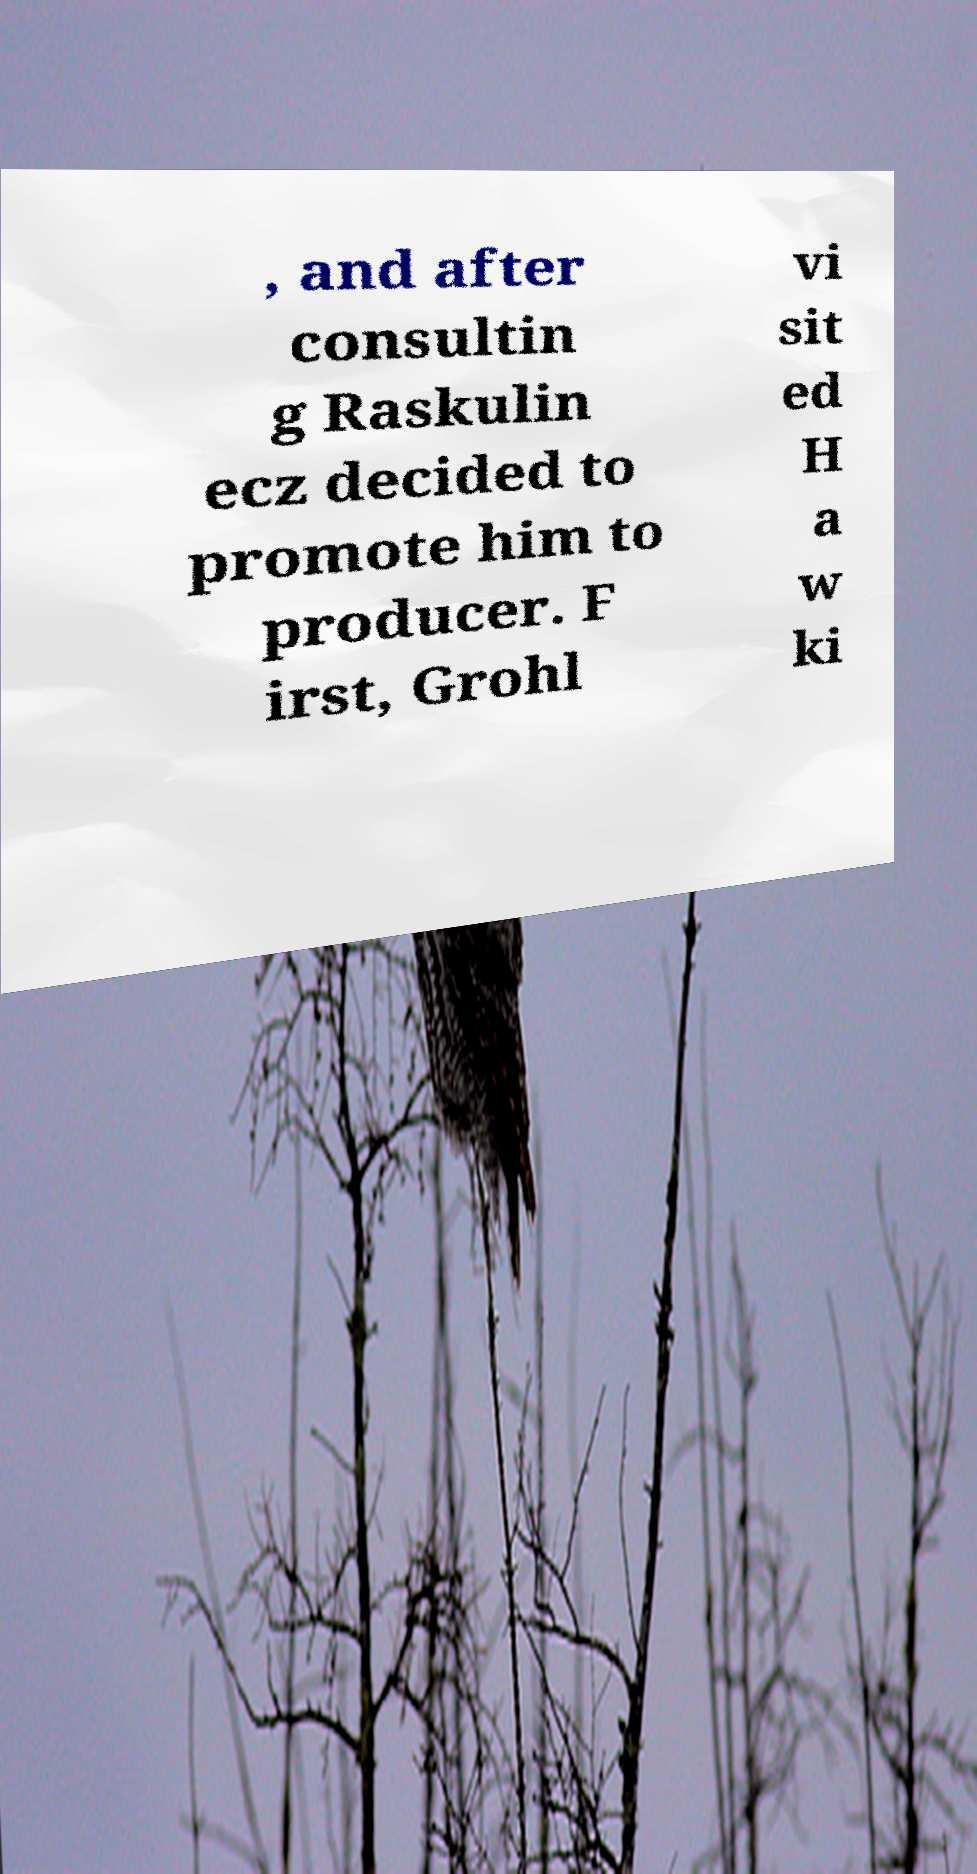Please read and relay the text visible in this image. What does it say? , and after consultin g Raskulin ecz decided to promote him to producer. F irst, Grohl vi sit ed H a w ki 